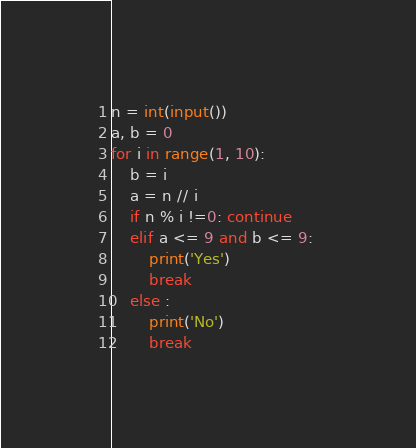<code> <loc_0><loc_0><loc_500><loc_500><_Python_>n = int(input())
a, b = 0
for i in range(1, 10):
    b = i
    a = n // i
    if n % i !=0: continue
    elif a <= 9 and b <= 9: 
        print('Yes')
        break
    else :
        print('No')
        break</code> 